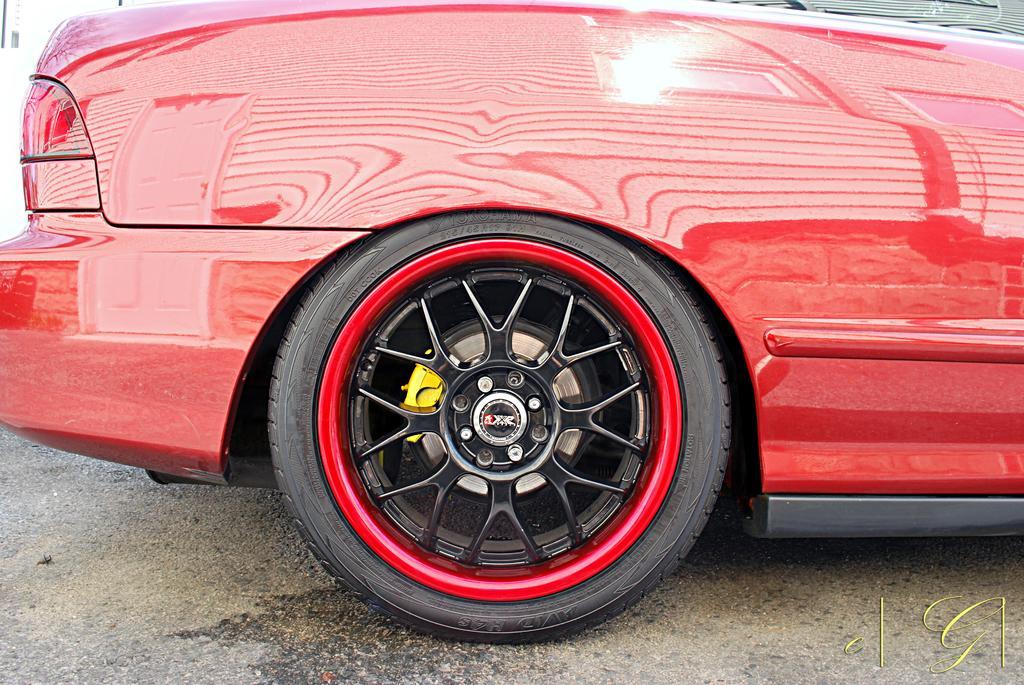Please provide a concise description of this image. In this image we can see a backside view of a car. At the bottom of the image there is the ground. On the image there is a watermark. 